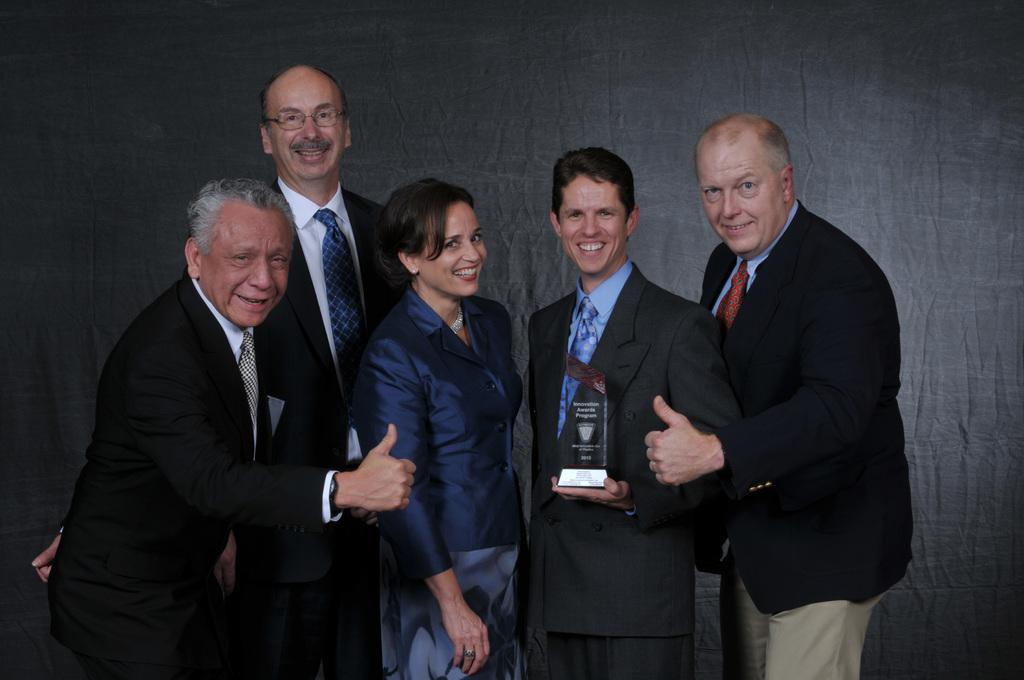How many people are in the image? There are five people in the image. What is the facial expression of the people in the image? All of them are smiling. Can you describe the gender distribution of the people in the image? Four of them are men, and one of them is a woman. What color is the background in the image? The background is in grey color. What type of house can be seen in the background of the image? There is no house present in the image; the background is in grey color. How does the woman in the image feel about the situation? The image does not provide any information about the feelings of the people in the image, as they are only depicted as smiling. 